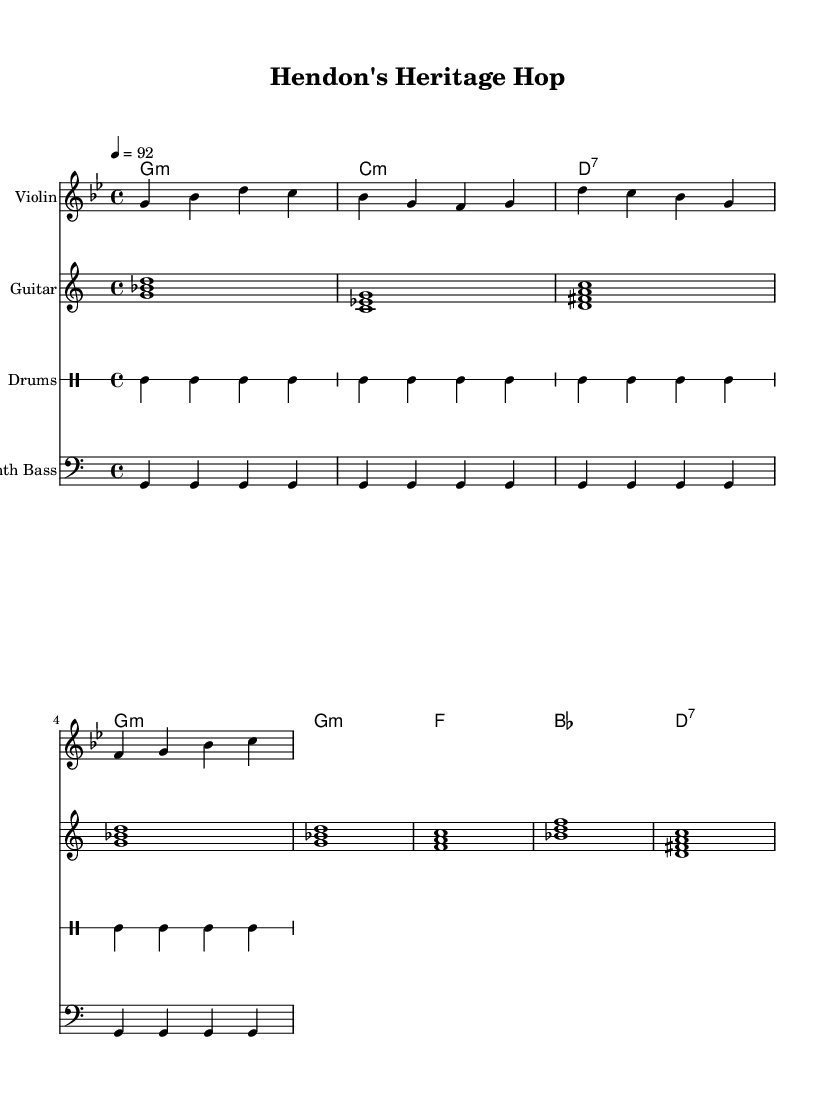What is the key signature of this music? The key signature is indicated at the beginning of the staff. It shows one flat, which corresponds to the key of G minor.
Answer: G minor What is the time signature of this piece? The time signature appears next to the key signature at the start of the music and is represented as a fraction. Here, it shows 4 over 4, indicating that there are four beats in each measure.
Answer: 4/4 What is the tempo marking for the piece? The tempo is indicated by the note value and number shown at the beginning. It specifies the speed of the piece, which is set to 92 beats per minute.
Answer: 92 How many bars are there in the intro section? The intro section consists of two measures visible at the beginning of the sheet music, as indicated by the bars separating notes.
Answer: 2 What is the primary instrument used for the melody? The title of the staff shows "Violin," which signifies that the violin plays the primary melody throughout the piece.
Answer: Violin Which chord appears most frequently in the verse section? By examining the chord progression in the verse, it shows that the G minor chord is repeated consistently, making it the most frequent chord in that section.
Answer: G minor What type of drum pattern is used in this piece? The drum part is indicated by a repeated pattern of bass and snare hits, commonly found in hip-hop. The specific notation visually reflects a steady beat with alternating bass and snare.
Answer: Hip-hop 